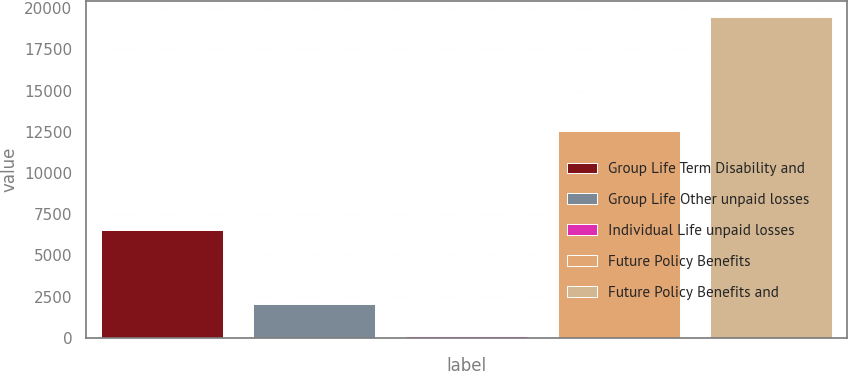Convert chart. <chart><loc_0><loc_0><loc_500><loc_500><bar_chart><fcel>Group Life Term Disability and<fcel>Group Life Other unpaid losses<fcel>Individual Life unpaid losses<fcel>Future Policy Benefits<fcel>Future Policy Benefits and<nl><fcel>6547<fcel>2067.2<fcel>134<fcel>12572<fcel>19466<nl></chart> 